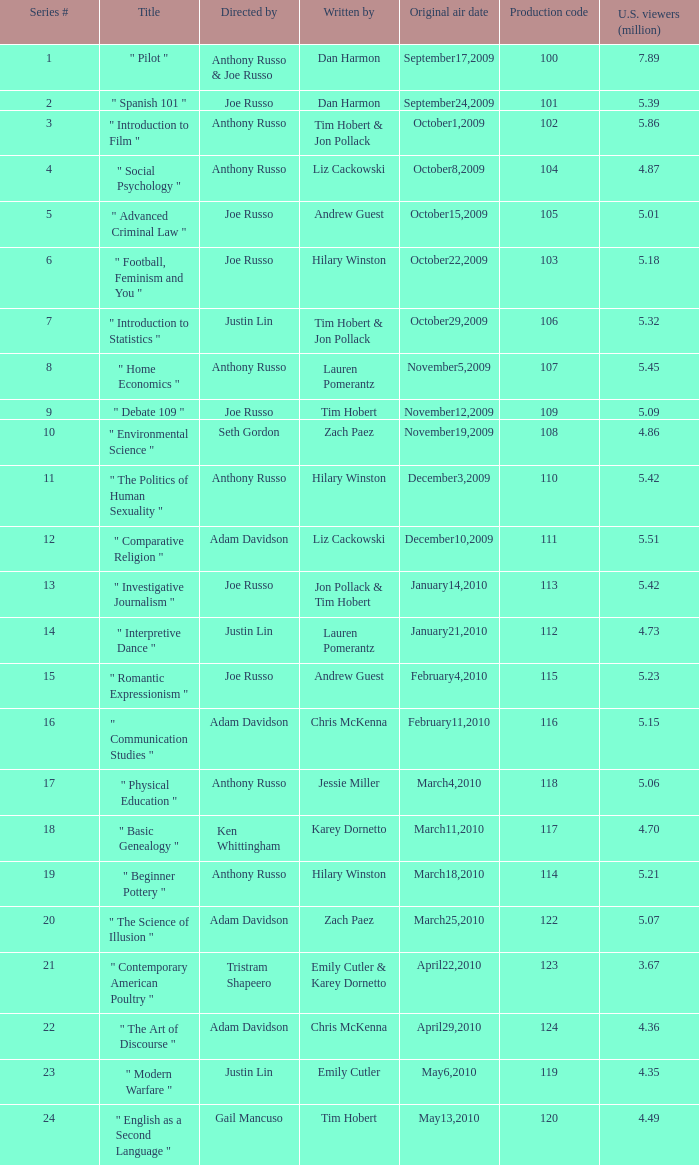How many episodes had a production code 120? 1.0. 